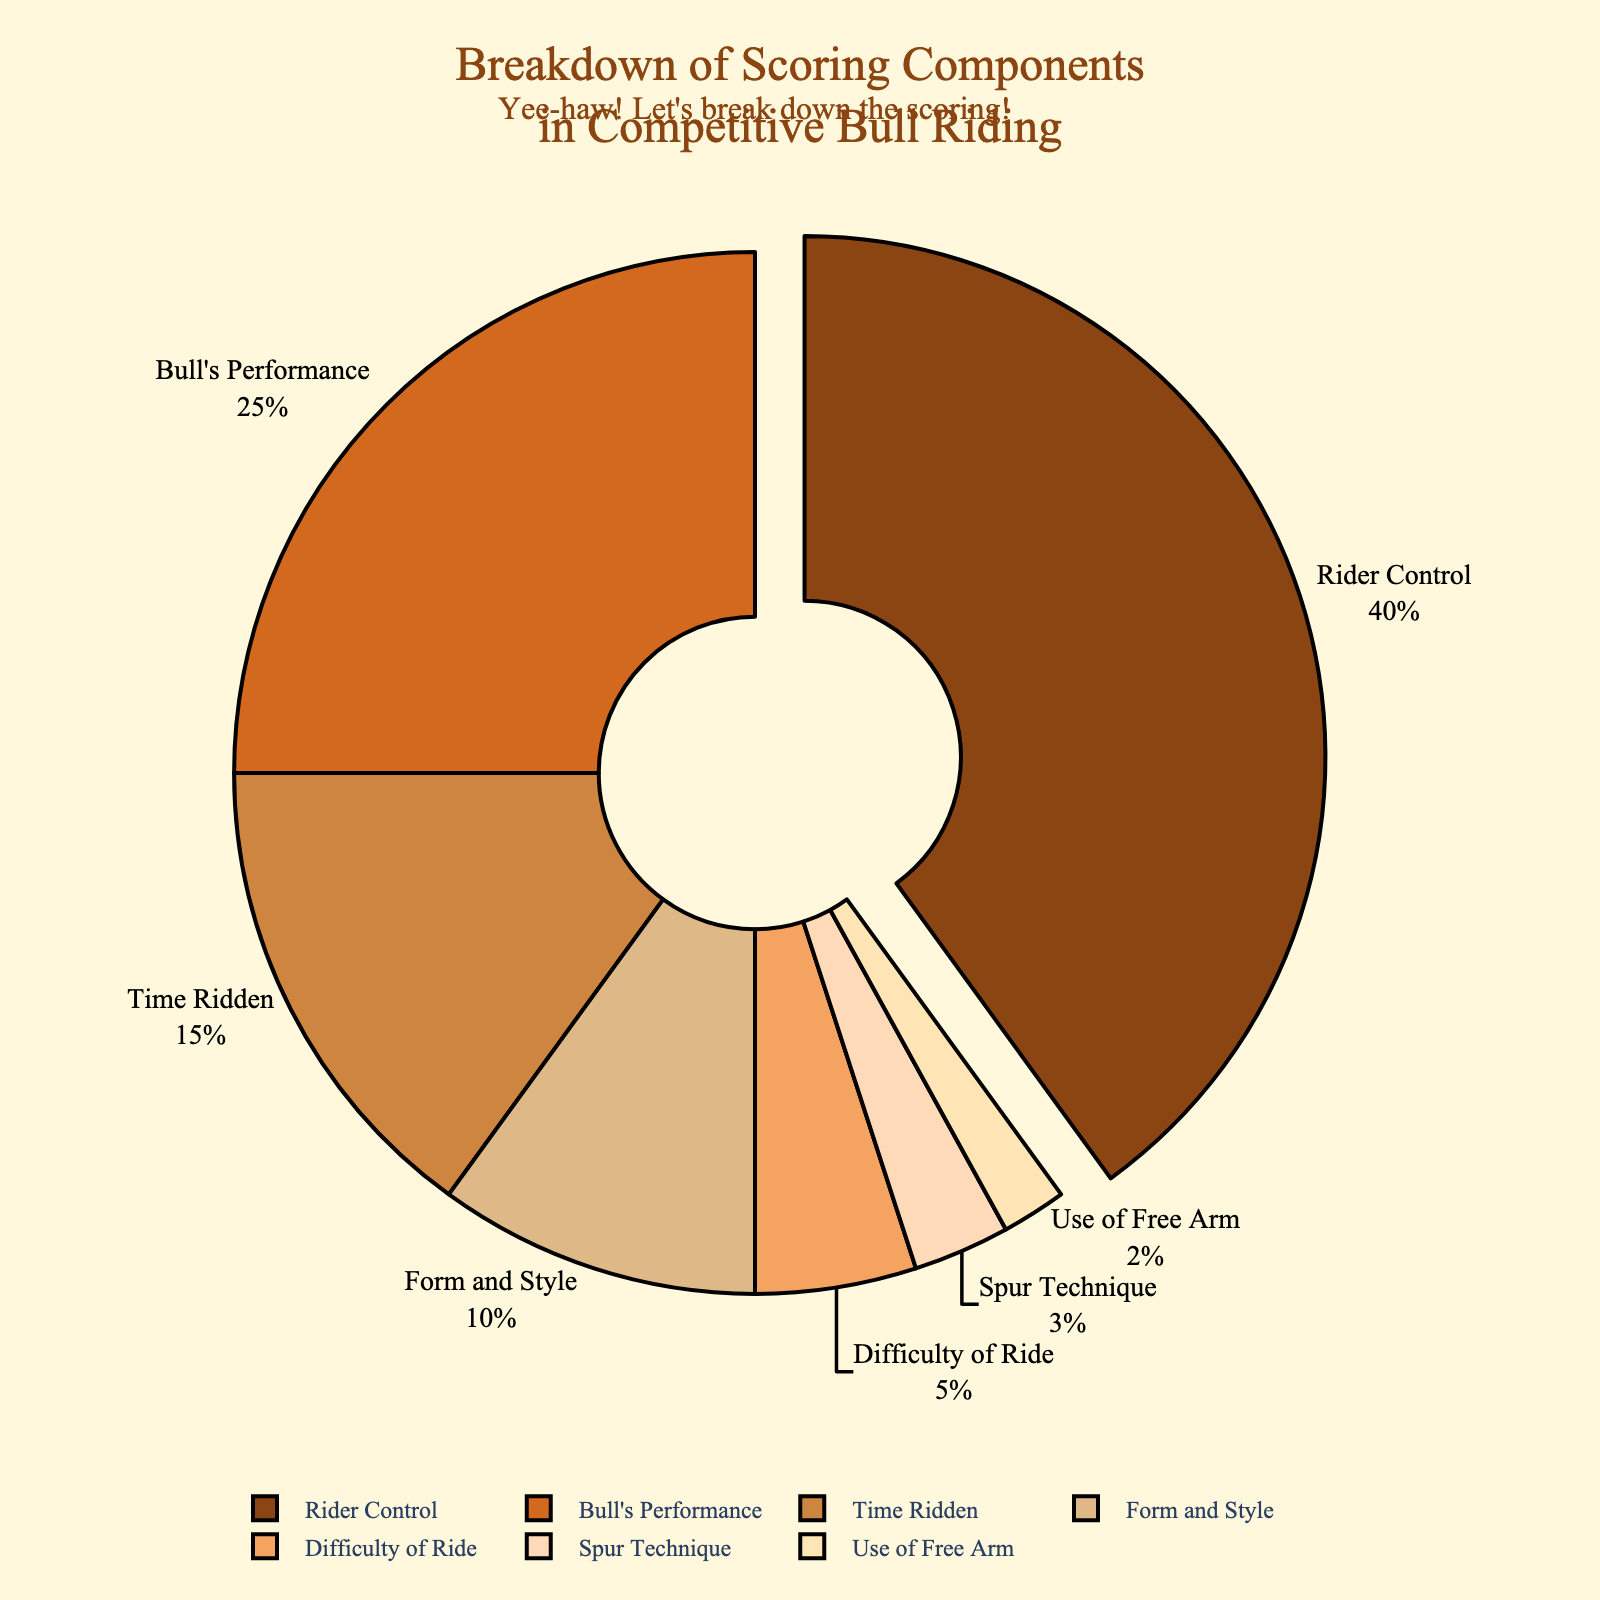Which scoring component has the highest percentage? The pie chart shows the percentages of different scoring components. The largest segment, which is slightly pulled out from the rest, represents "Rider Control" with the highest percentage.
Answer: Rider Control How much greater is the percentage of Rider Control compared to Bull's Performance? Rider Control accounts for 40% while Bull's Performance accounts for 25%. The difference between the two is calculated as 40% - 25% = 15%.
Answer: 15% What is the combined percentage of Time Ridden and Form and Style? Time Ridden is 15% and Form and Style is 10%. Adding these two together, 15% + 10% = 25%.
Answer: 25% Which components have a percentage less than 10%? The components with less than 10% are "Difficulty of Ride" (5%), "Spur Technique" (3%), and "Use of Free Arm" (2%).
Answer: Difficulty of Ride, Spur Technique, Use of Free Arm What's the difference between the highest and the lowest percentage components? The highest percentage component is "Rider Control" at 40%, and the lowest is "Use of Free Arm" at 2%. The difference is calculated as 40% - 2% = 38%.
Answer: 38% Which category is represented by the lightest color in the pie chart? The lightest color in the pie chart corresponds to the segment for "Use of Free Arm," which has the smallest percentage of 2%.
Answer: Use of Free Arm If you sum the percentages of categories with double-digit values, what is the total? The categories with double-digit values are Rider Control (40%), Bull's Performance (25%), Time Ridden (15%), and Form and Style (10%). Summing these, we get 40% + 25% + 15% + 10% = 90%.
Answer: 90% 